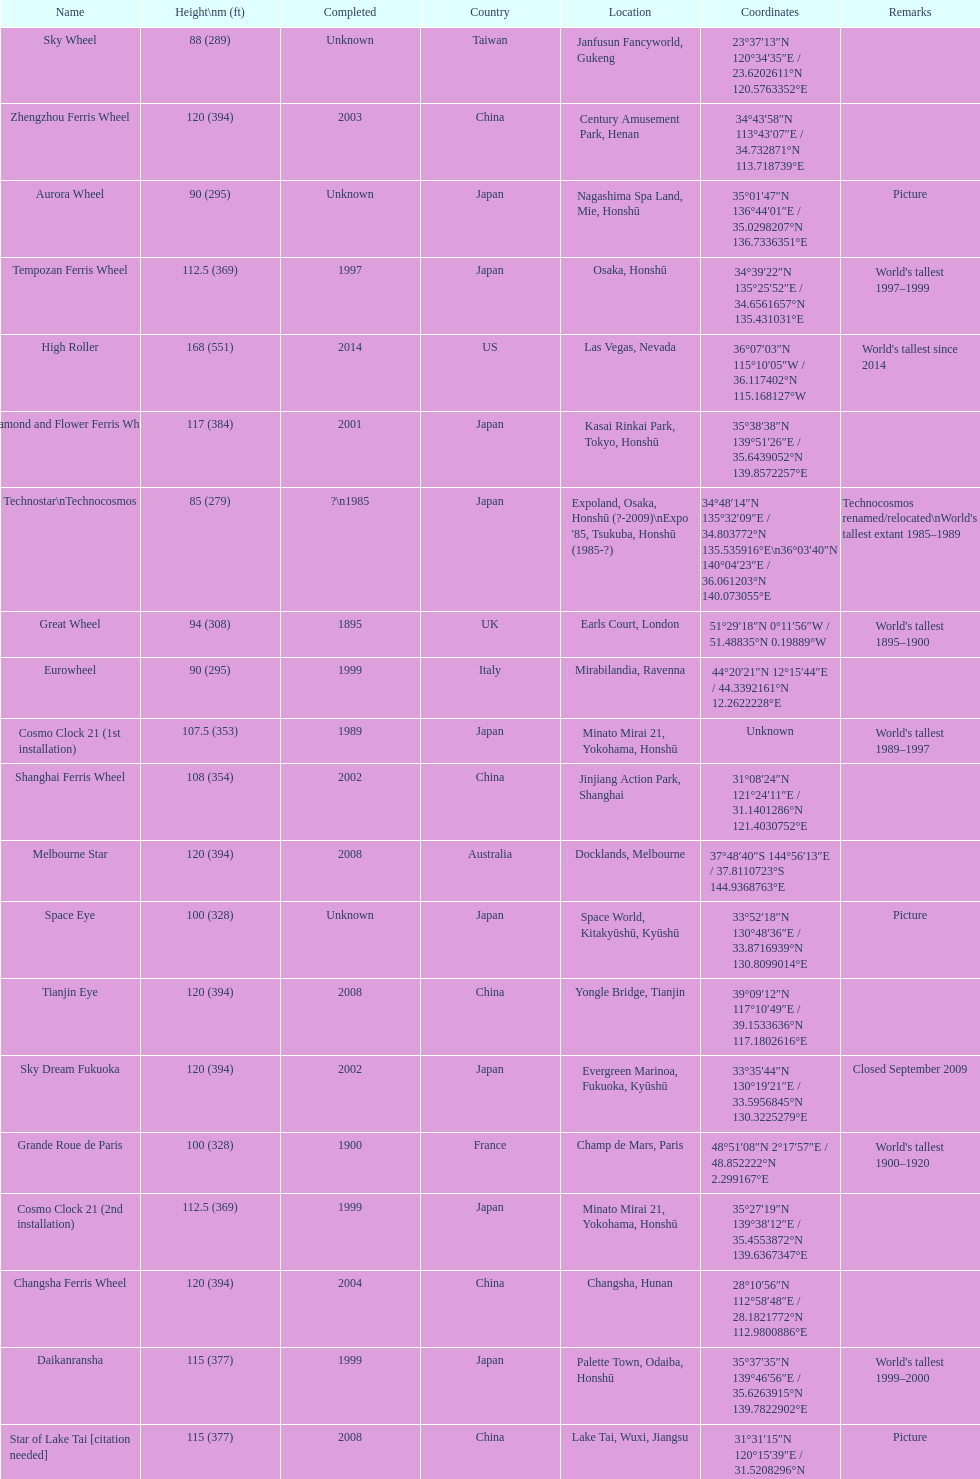Help me parse the entirety of this table. {'header': ['Name', 'Height\\nm (ft)', 'Completed', 'Country', 'Location', 'Coordinates', 'Remarks'], 'rows': [['Sky Wheel', '88 (289)', 'Unknown', 'Taiwan', 'Janfusun Fancyworld, Gukeng', '23°37′13″N 120°34′35″E\ufeff / \ufeff23.6202611°N 120.5763352°E', ''], ['Zhengzhou Ferris Wheel', '120 (394)', '2003', 'China', 'Century Amusement Park, Henan', '34°43′58″N 113°43′07″E\ufeff / \ufeff34.732871°N 113.718739°E', ''], ['Aurora Wheel', '90 (295)', 'Unknown', 'Japan', 'Nagashima Spa Land, Mie, Honshū', '35°01′47″N 136°44′01″E\ufeff / \ufeff35.0298207°N 136.7336351°E', 'Picture'], ['Tempozan Ferris Wheel', '112.5 (369)', '1997', 'Japan', 'Osaka, Honshū', '34°39′22″N 135°25′52″E\ufeff / \ufeff34.6561657°N 135.431031°E', "World's tallest 1997–1999"], ['High Roller', '168 (551)', '2014', 'US', 'Las Vegas, Nevada', '36°07′03″N 115°10′05″W\ufeff / \ufeff36.117402°N 115.168127°W', "World's tallest since 2014"], ['Diamond\xa0and\xa0Flower\xa0Ferris\xa0Wheel', '117 (384)', '2001', 'Japan', 'Kasai Rinkai Park, Tokyo, Honshū', '35°38′38″N 139°51′26″E\ufeff / \ufeff35.6439052°N 139.8572257°E', ''], ['Technostar\\nTechnocosmos', '85 (279)', '?\\n1985', 'Japan', "Expoland, Osaka, Honshū (?-2009)\\nExpo '85, Tsukuba, Honshū (1985-?)", '34°48′14″N 135°32′09″E\ufeff / \ufeff34.803772°N 135.535916°E\\n36°03′40″N 140°04′23″E\ufeff / \ufeff36.061203°N 140.073055°E', "Technocosmos renamed/relocated\\nWorld's tallest extant 1985–1989"], ['Great Wheel', '94 (308)', '1895', 'UK', 'Earls Court, London', '51°29′18″N 0°11′56″W\ufeff / \ufeff51.48835°N 0.19889°W', "World's tallest 1895–1900"], ['Eurowheel', '90 (295)', '1999', 'Italy', 'Mirabilandia, Ravenna', '44°20′21″N 12°15′44″E\ufeff / \ufeff44.3392161°N 12.2622228°E', ''], ['Cosmo Clock 21 (1st installation)', '107.5 (353)', '1989', 'Japan', 'Minato Mirai 21, Yokohama, Honshū', 'Unknown', "World's tallest 1989–1997"], ['Shanghai Ferris Wheel', '108 (354)', '2002', 'China', 'Jinjiang Action Park, Shanghai', '31°08′24″N 121°24′11″E\ufeff / \ufeff31.1401286°N 121.4030752°E', ''], ['Melbourne Star', '120 (394)', '2008', 'Australia', 'Docklands, Melbourne', '37°48′40″S 144°56′13″E\ufeff / \ufeff37.8110723°S 144.9368763°E', ''], ['Space Eye', '100 (328)', 'Unknown', 'Japan', 'Space World, Kitakyūshū, Kyūshū', '33°52′18″N 130°48′36″E\ufeff / \ufeff33.8716939°N 130.8099014°E', 'Picture'], ['Tianjin Eye', '120 (394)', '2008', 'China', 'Yongle Bridge, Tianjin', '39°09′12″N 117°10′49″E\ufeff / \ufeff39.1533636°N 117.1802616°E', ''], ['Sky Dream Fukuoka', '120 (394)', '2002', 'Japan', 'Evergreen Marinoa, Fukuoka, Kyūshū', '33°35′44″N 130°19′21″E\ufeff / \ufeff33.5956845°N 130.3225279°E', 'Closed September 2009'], ['Grande Roue de Paris', '100 (328)', '1900', 'France', 'Champ de Mars, Paris', '48°51′08″N 2°17′57″E\ufeff / \ufeff48.852222°N 2.299167°E', "World's tallest 1900–1920"], ['Cosmo Clock 21 (2nd installation)', '112.5 (369)', '1999', 'Japan', 'Minato Mirai 21, Yokohama, Honshū', '35°27′19″N 139°38′12″E\ufeff / \ufeff35.4553872°N 139.6367347°E', ''], ['Changsha Ferris Wheel', '120 (394)', '2004', 'China', 'Changsha, Hunan', '28°10′56″N 112°58′48″E\ufeff / \ufeff28.1821772°N 112.9800886°E', ''], ['Daikanransha', '115 (377)', '1999', 'Japan', 'Palette Town, Odaiba, Honshū', '35°37′35″N 139°46′56″E\ufeff / \ufeff35.6263915°N 139.7822902°E', "World's tallest 1999–2000"], ['Star of Lake Tai\xa0[citation needed]', '115 (377)', '2008', 'China', 'Lake Tai, Wuxi, Jiangsu', '31°31′15″N 120°15′39″E\ufeff / \ufeff31.5208296°N 120.260945°E', 'Picture'], ['The original Ferris Wheel', '80.4 (264)', '1893', 'US', 'Chicago (1893–1903); St. Louis (1904–06)', 'Ferris Wheel coordinates', "World's tallest 1893–1894"], ['Suzhou Ferris Wheel', '120 (394)', '2009', 'China', 'Suzhou, Jiangsu', '31°18′59″N 120°42′30″E\ufeff / \ufeff31.3162939°N 120.7084501°E', ''], ['Singapore Flyer', '165 (541)', '2008', 'Singapore', 'Marina Centre, Downtown Core', '1°17′22″N 103°51′48″E\ufeff / \ufeff1.289397°N 103.863231°E', "World's tallest 2008-2014"], ['Harbin Ferris Wheel', '110 (361)', '2003', 'China', 'Harbin, Heilongjiang', '45°46′40″N 126°39′48″E\ufeff / \ufeff45.7776481°N 126.6634637°E', 'Picture'], ['Star of Nanchang', '160 (525)', '2006', 'China', 'Nanchang, Jiangxi', '28°39′34″N 115°50′44″E\ufeff / \ufeff28.659332°N 115.845568°E', "World's tallest 2006–2008"], ['London Eye', '135 (443)', '2000', 'UK', 'South Bank, Lambeth, London', '51°30′12″N 0°07′11″W\ufeff / \ufeff51.50334°N 0.1197821°W', "World's tallest 2000–2006"]]} Where was the original tallest roller coster built? Chicago. 